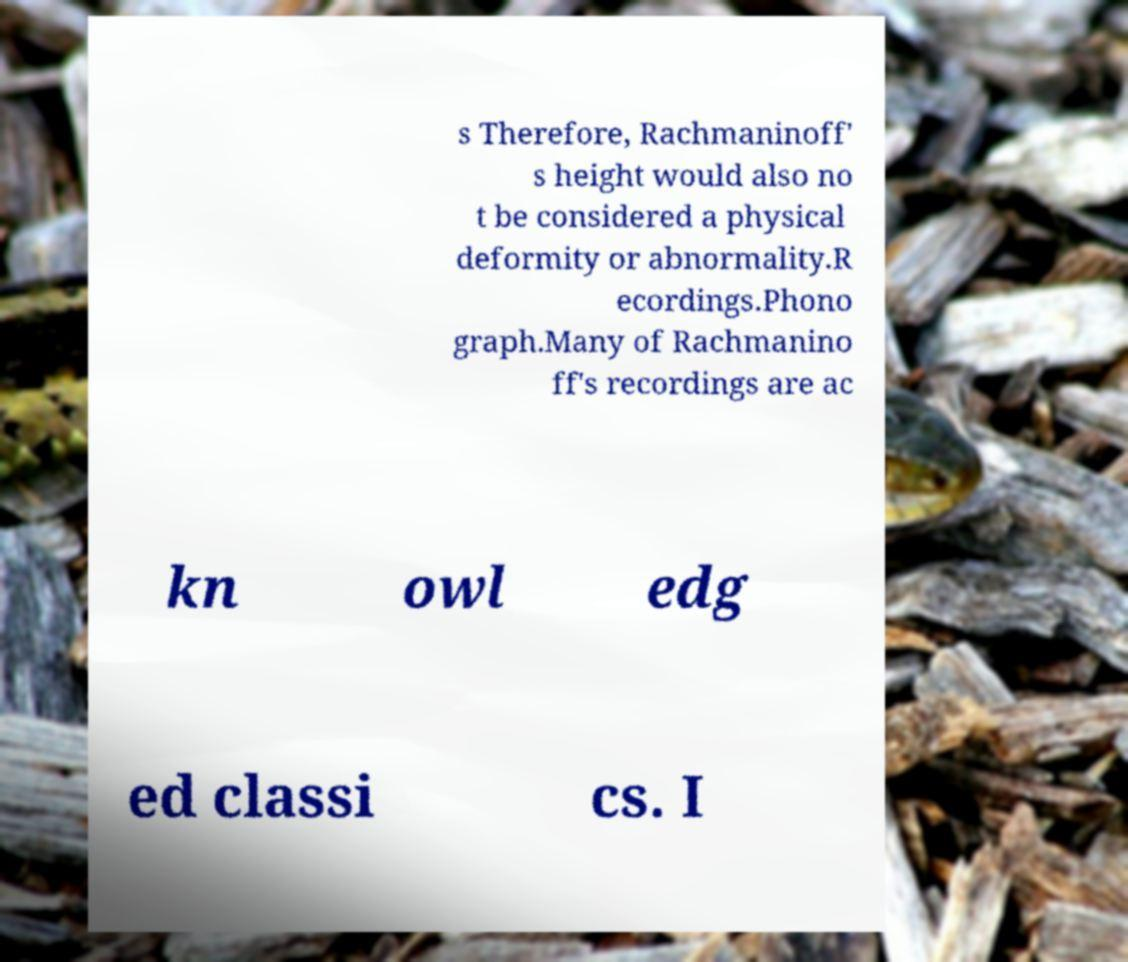Could you extract and type out the text from this image? s Therefore, Rachmaninoff' s height would also no t be considered a physical deformity or abnormality.R ecordings.Phono graph.Many of Rachmanino ff's recordings are ac kn owl edg ed classi cs. I 